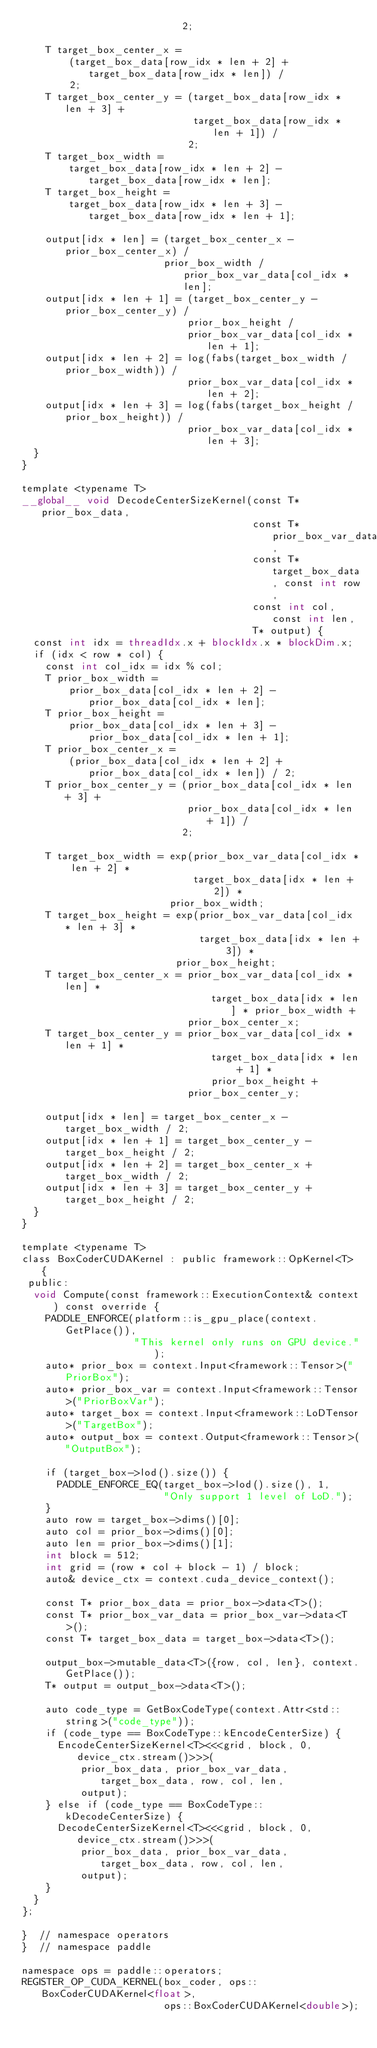Convert code to text. <code><loc_0><loc_0><loc_500><loc_500><_Cuda_>                           2;

    T target_box_center_x =
        (target_box_data[row_idx * len + 2] + target_box_data[row_idx * len]) /
        2;
    T target_box_center_y = (target_box_data[row_idx * len + 3] +
                             target_box_data[row_idx * len + 1]) /
                            2;
    T target_box_width =
        target_box_data[row_idx * len + 2] - target_box_data[row_idx * len];
    T target_box_height =
        target_box_data[row_idx * len + 3] - target_box_data[row_idx * len + 1];

    output[idx * len] = (target_box_center_x - prior_box_center_x) /
                        prior_box_width / prior_box_var_data[col_idx * len];
    output[idx * len + 1] = (target_box_center_y - prior_box_center_y) /
                            prior_box_height /
                            prior_box_var_data[col_idx * len + 1];
    output[idx * len + 2] = log(fabs(target_box_width / prior_box_width)) /
                            prior_box_var_data[col_idx * len + 2];
    output[idx * len + 3] = log(fabs(target_box_height / prior_box_height)) /
                            prior_box_var_data[col_idx * len + 3];
  }
}

template <typename T>
__global__ void DecodeCenterSizeKernel(const T* prior_box_data,
                                       const T* prior_box_var_data,
                                       const T* target_box_data, const int row,
                                       const int col, const int len,
                                       T* output) {
  const int idx = threadIdx.x + blockIdx.x * blockDim.x;
  if (idx < row * col) {
    const int col_idx = idx % col;
    T prior_box_width =
        prior_box_data[col_idx * len + 2] - prior_box_data[col_idx * len];
    T prior_box_height =
        prior_box_data[col_idx * len + 3] - prior_box_data[col_idx * len + 1];
    T prior_box_center_x =
        (prior_box_data[col_idx * len + 2] + prior_box_data[col_idx * len]) / 2;
    T prior_box_center_y = (prior_box_data[col_idx * len + 3] +
                            prior_box_data[col_idx * len + 1]) /
                           2;

    T target_box_width = exp(prior_box_var_data[col_idx * len + 2] *
                             target_box_data[idx * len + 2]) *
                         prior_box_width;
    T target_box_height = exp(prior_box_var_data[col_idx * len + 3] *
                              target_box_data[idx * len + 3]) *
                          prior_box_height;
    T target_box_center_x = prior_box_var_data[col_idx * len] *
                                target_box_data[idx * len] * prior_box_width +
                            prior_box_center_x;
    T target_box_center_y = prior_box_var_data[col_idx * len + 1] *
                                target_box_data[idx * len + 1] *
                                prior_box_height +
                            prior_box_center_y;

    output[idx * len] = target_box_center_x - target_box_width / 2;
    output[idx * len + 1] = target_box_center_y - target_box_height / 2;
    output[idx * len + 2] = target_box_center_x + target_box_width / 2;
    output[idx * len + 3] = target_box_center_y + target_box_height / 2;
  }
}

template <typename T>
class BoxCoderCUDAKernel : public framework::OpKernel<T> {
 public:
  void Compute(const framework::ExecutionContext& context) const override {
    PADDLE_ENFORCE(platform::is_gpu_place(context.GetPlace()),
                   "This kernel only runs on GPU device.");
    auto* prior_box = context.Input<framework::Tensor>("PriorBox");
    auto* prior_box_var = context.Input<framework::Tensor>("PriorBoxVar");
    auto* target_box = context.Input<framework::LoDTensor>("TargetBox");
    auto* output_box = context.Output<framework::Tensor>("OutputBox");

    if (target_box->lod().size()) {
      PADDLE_ENFORCE_EQ(target_box->lod().size(), 1,
                        "Only support 1 level of LoD.");
    }
    auto row = target_box->dims()[0];
    auto col = prior_box->dims()[0];
    auto len = prior_box->dims()[1];
    int block = 512;
    int grid = (row * col + block - 1) / block;
    auto& device_ctx = context.cuda_device_context();

    const T* prior_box_data = prior_box->data<T>();
    const T* prior_box_var_data = prior_box_var->data<T>();
    const T* target_box_data = target_box->data<T>();

    output_box->mutable_data<T>({row, col, len}, context.GetPlace());
    T* output = output_box->data<T>();

    auto code_type = GetBoxCodeType(context.Attr<std::string>("code_type"));
    if (code_type == BoxCodeType::kEncodeCenterSize) {
      EncodeCenterSizeKernel<T><<<grid, block, 0, device_ctx.stream()>>>(
          prior_box_data, prior_box_var_data, target_box_data, row, col, len,
          output);
    } else if (code_type == BoxCodeType::kDecodeCenterSize) {
      DecodeCenterSizeKernel<T><<<grid, block, 0, device_ctx.stream()>>>(
          prior_box_data, prior_box_var_data, target_box_data, row, col, len,
          output);
    }
  }
};

}  // namespace operators
}  // namespace paddle

namespace ops = paddle::operators;
REGISTER_OP_CUDA_KERNEL(box_coder, ops::BoxCoderCUDAKernel<float>,
                        ops::BoxCoderCUDAKernel<double>);
</code> 